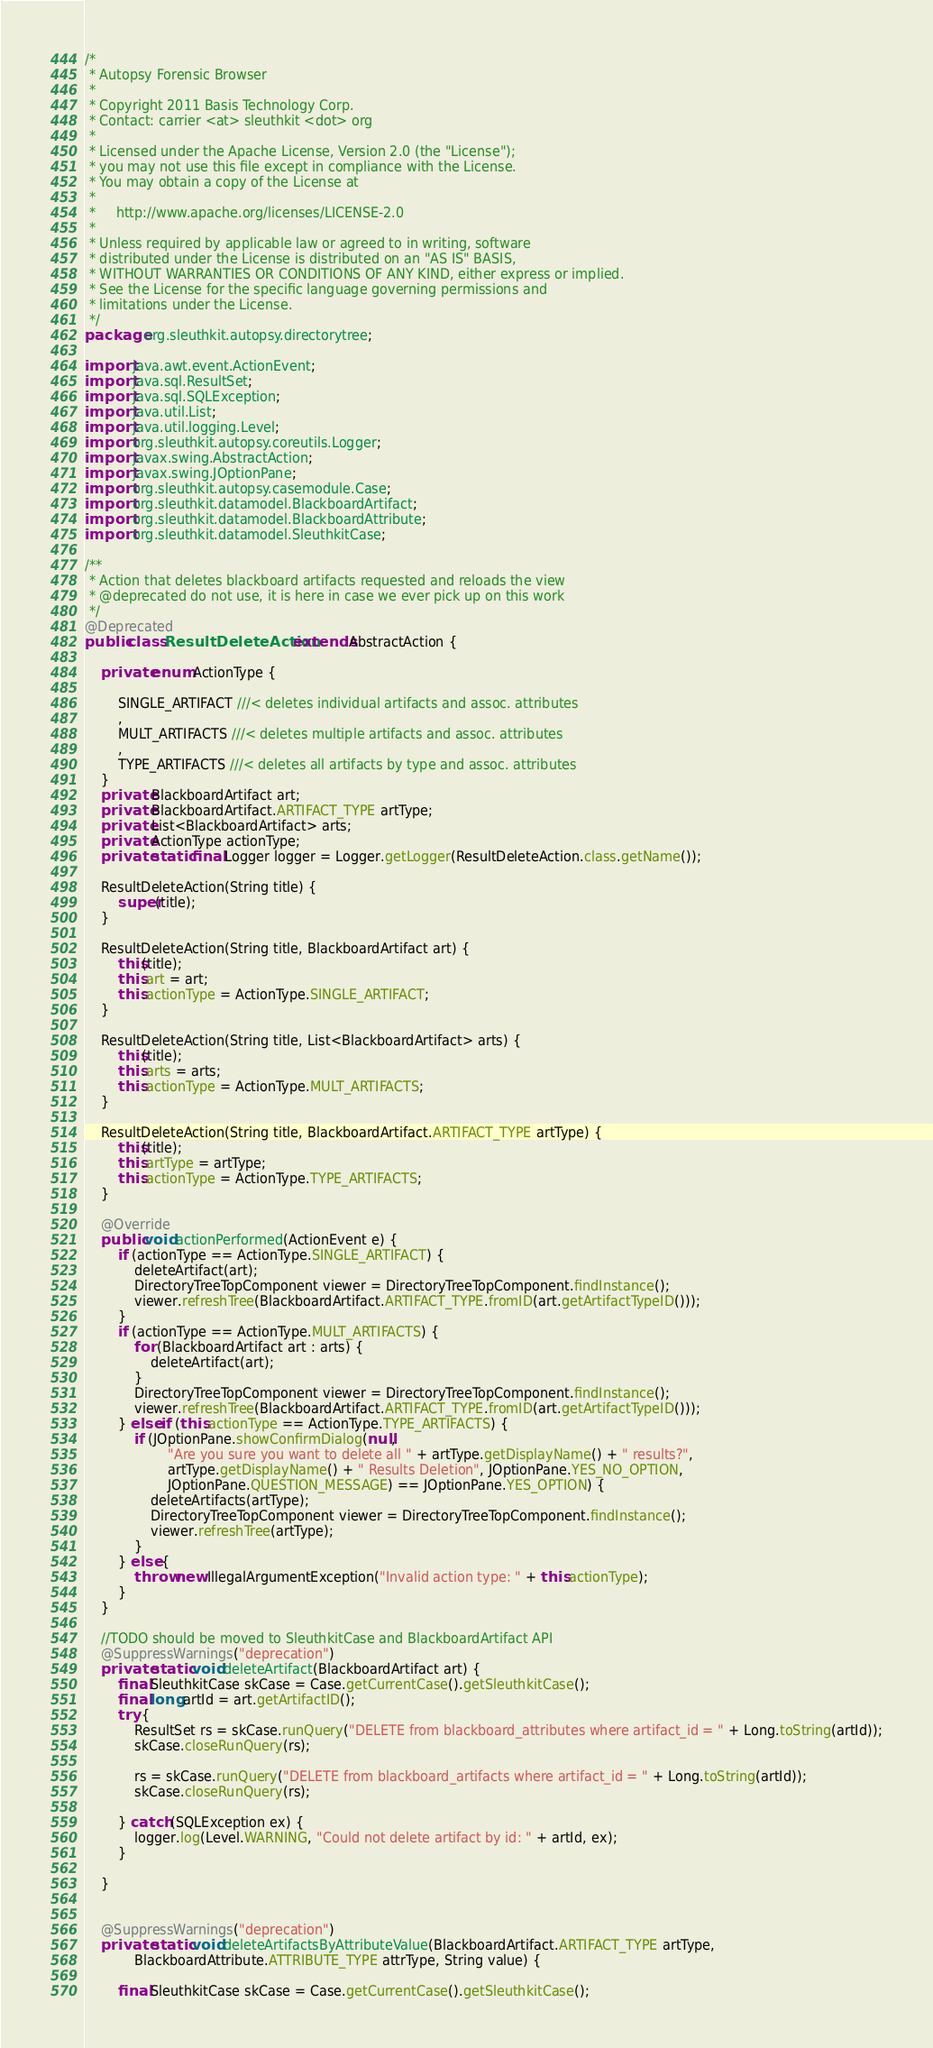Convert code to text. <code><loc_0><loc_0><loc_500><loc_500><_Java_>/*
 * Autopsy Forensic Browser
 * 
 * Copyright 2011 Basis Technology Corp.
 * Contact: carrier <at> sleuthkit <dot> org
 * 
 * Licensed under the Apache License, Version 2.0 (the "License");
 * you may not use this file except in compliance with the License.
 * You may obtain a copy of the License at
 * 
 *     http://www.apache.org/licenses/LICENSE-2.0
 * 
 * Unless required by applicable law or agreed to in writing, software
 * distributed under the License is distributed on an "AS IS" BASIS,
 * WITHOUT WARRANTIES OR CONDITIONS OF ANY KIND, either express or implied.
 * See the License for the specific language governing permissions and
 * limitations under the License.
 */
package org.sleuthkit.autopsy.directorytree;

import java.awt.event.ActionEvent;
import java.sql.ResultSet;
import java.sql.SQLException;
import java.util.List;
import java.util.logging.Level;
import org.sleuthkit.autopsy.coreutils.Logger;
import javax.swing.AbstractAction;
import javax.swing.JOptionPane;
import org.sleuthkit.autopsy.casemodule.Case;
import org.sleuthkit.datamodel.BlackboardArtifact;
import org.sleuthkit.datamodel.BlackboardAttribute;
import org.sleuthkit.datamodel.SleuthkitCase;

/**
 * Action that deletes blackboard artifacts requested and reloads the view
 * @deprecated do not use, it is here in case we ever pick up on this work
 */
@Deprecated
public class ResultDeleteAction extends AbstractAction {

    private enum ActionType {

        SINGLE_ARTIFACT ///< deletes individual artifacts and assoc. attributes
        ,
        MULT_ARTIFACTS ///< deletes multiple artifacts and assoc. attributes
        ,
        TYPE_ARTIFACTS ///< deletes all artifacts by type and assoc. attributes
    }
    private BlackboardArtifact art;
    private BlackboardArtifact.ARTIFACT_TYPE artType;
    private List<BlackboardArtifact> arts;
    private ActionType actionType;
    private static final Logger logger = Logger.getLogger(ResultDeleteAction.class.getName());

    ResultDeleteAction(String title) {
        super(title);
    }

    ResultDeleteAction(String title, BlackboardArtifact art) {
        this(title);
        this.art = art;
        this.actionType = ActionType.SINGLE_ARTIFACT;
    }

    ResultDeleteAction(String title, List<BlackboardArtifact> arts) {
        this(title);
        this.arts = arts;
        this.actionType = ActionType.MULT_ARTIFACTS;
    }

    ResultDeleteAction(String title, BlackboardArtifact.ARTIFACT_TYPE artType) {
        this(title);
        this.artType = artType;
        this.actionType = ActionType.TYPE_ARTIFACTS;
    }

    @Override
    public void actionPerformed(ActionEvent e) {
        if (actionType == ActionType.SINGLE_ARTIFACT) {
            deleteArtifact(art);
            DirectoryTreeTopComponent viewer = DirectoryTreeTopComponent.findInstance();
            viewer.refreshTree(BlackboardArtifact.ARTIFACT_TYPE.fromID(art.getArtifactTypeID()));
        }
        if (actionType == ActionType.MULT_ARTIFACTS) {
            for (BlackboardArtifact art : arts) {
                deleteArtifact(art);
            }
            DirectoryTreeTopComponent viewer = DirectoryTreeTopComponent.findInstance();
            viewer.refreshTree(BlackboardArtifact.ARTIFACT_TYPE.fromID(art.getArtifactTypeID()));
        } else if (this.actionType == ActionType.TYPE_ARTIFACTS) {
            if (JOptionPane.showConfirmDialog(null,
                    "Are you sure you want to delete all " + artType.getDisplayName() + " results?",
                    artType.getDisplayName() + " Results Deletion", JOptionPane.YES_NO_OPTION,
                    JOptionPane.QUESTION_MESSAGE) == JOptionPane.YES_OPTION) {
                deleteArtifacts(artType);
                DirectoryTreeTopComponent viewer = DirectoryTreeTopComponent.findInstance();
                viewer.refreshTree(artType);
            }
        } else {
            throw new IllegalArgumentException("Invalid action type: " + this.actionType);
        }
    }

    //TODO should be moved to SleuthkitCase and BlackboardArtifact API
    @SuppressWarnings("deprecation")
    private static void deleteArtifact(BlackboardArtifact art) {
        final SleuthkitCase skCase = Case.getCurrentCase().getSleuthkitCase();
        final long artId = art.getArtifactID();
        try {
            ResultSet rs = skCase.runQuery("DELETE from blackboard_attributes where artifact_id = " + Long.toString(artId));
            skCase.closeRunQuery(rs);

            rs = skCase.runQuery("DELETE from blackboard_artifacts where artifact_id = " + Long.toString(artId));
            skCase.closeRunQuery(rs);

        } catch (SQLException ex) {
            logger.log(Level.WARNING, "Could not delete artifact by id: " + artId, ex);
        }

    }


    @SuppressWarnings("deprecation")
    private static void deleteArtifactsByAttributeValue(BlackboardArtifact.ARTIFACT_TYPE artType,
            BlackboardAttribute.ATTRIBUTE_TYPE attrType, String value) {

        final SleuthkitCase skCase = Case.getCurrentCase().getSleuthkitCase();</code> 